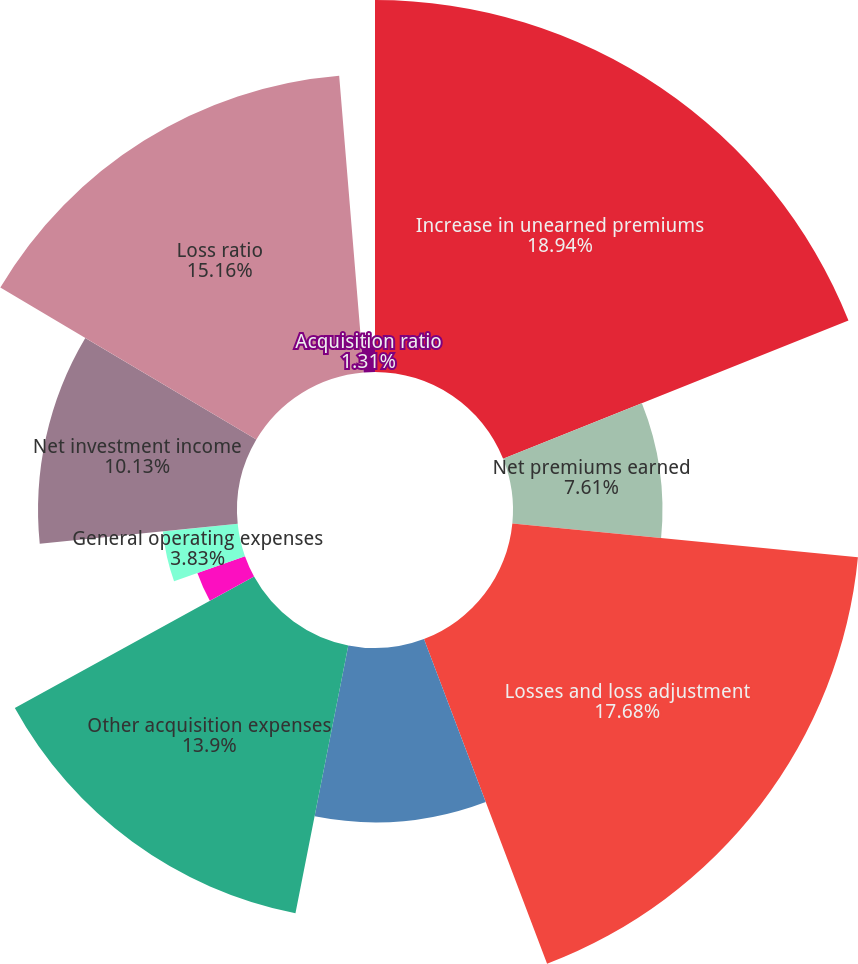Convert chart. <chart><loc_0><loc_0><loc_500><loc_500><pie_chart><fcel>Increase in unearned premiums<fcel>Net premiums earned<fcel>Losses and loss adjustment<fcel>Amortization of deferred<fcel>Other acquisition expenses<fcel>Total acquisition expenses<fcel>General operating expenses<fcel>Net investment income<fcel>Loss ratio<fcel>Acquisition ratio<nl><fcel>18.94%<fcel>7.61%<fcel>17.68%<fcel>8.87%<fcel>13.9%<fcel>2.57%<fcel>3.83%<fcel>10.13%<fcel>15.16%<fcel>1.31%<nl></chart> 